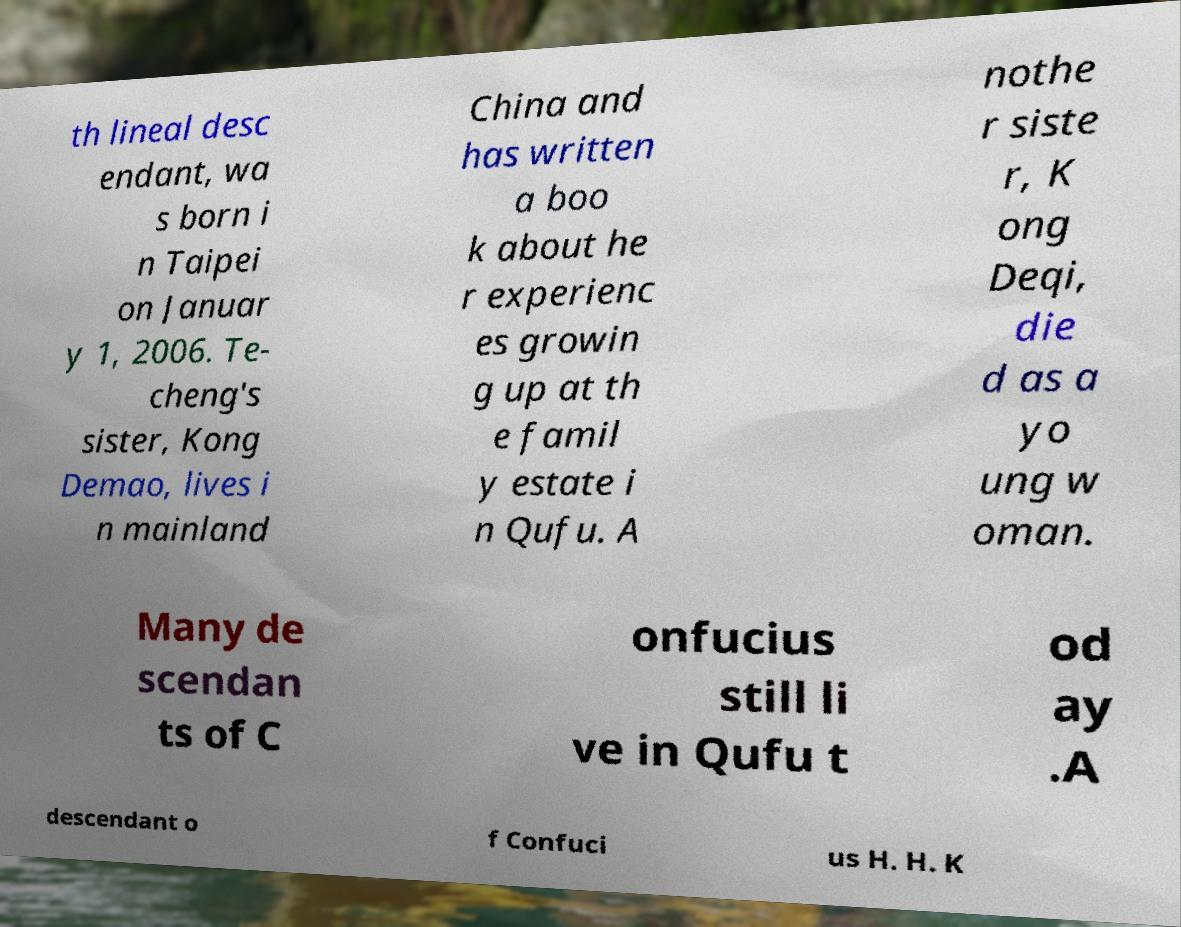Could you extract and type out the text from this image? th lineal desc endant, wa s born i n Taipei on Januar y 1, 2006. Te- cheng's sister, Kong Demao, lives i n mainland China and has written a boo k about he r experienc es growin g up at th e famil y estate i n Qufu. A nothe r siste r, K ong Deqi, die d as a yo ung w oman. Many de scendan ts of C onfucius still li ve in Qufu t od ay .A descendant o f Confuci us H. H. K 